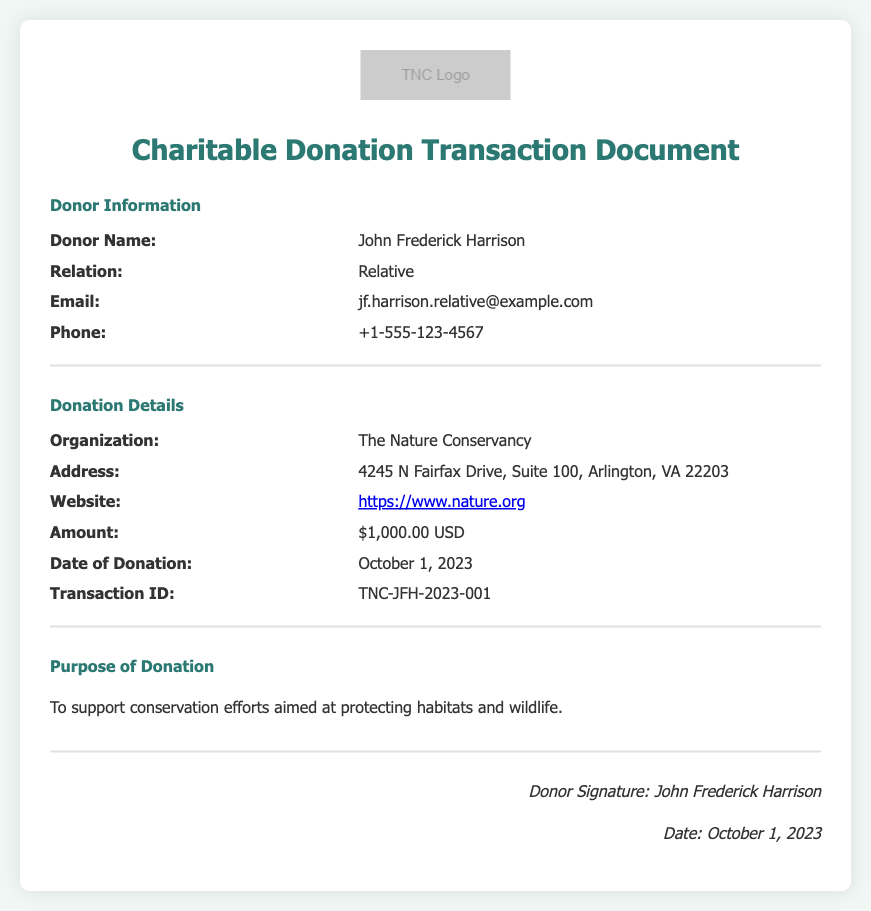What is the donor's name? The donor's name is mentioned in the Donor Information section of the document.
Answer: John Frederick Harrison What is the organization receiving the donation? The organization name is provided under the Donation Details section.
Answer: The Nature Conservancy What was the amount of the donation? The document specifies the donation amount in the Donation Details section.
Answer: $1,000.00 USD On what date was the donation made? The date of the donation is found in the Donation Details section.
Answer: October 1, 2023 What is the purpose of the donation? The purpose of the donation is outlined in the Purpose of Donation section of the document.
Answer: To support conservation efforts aimed at protecting habitats and wildlife How can I access the organization's website? The website link is provided in the Donation Details section and allows for instant access.
Answer: https://www.nature.org What is the transaction ID for this donation? The unique transaction ID is listed in the Donation Details section of the document.
Answer: TNC-JFH-2023-001 What relation does the author of the document have with the donor? The relationship is explicitly stated in the Donor Information section.
Answer: Relative 